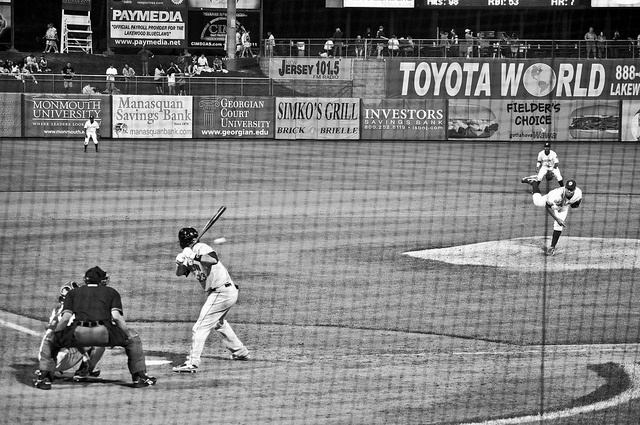Describe the objects in this image and their specific colors. I can see people in darkgray, black, gray, and lightgray tones, people in darkgray, black, gray, and lightgray tones, people in darkgray, lightgray, black, and gray tones, people in darkgray, white, black, and gray tones, and people in darkgray, white, gray, and black tones in this image. 